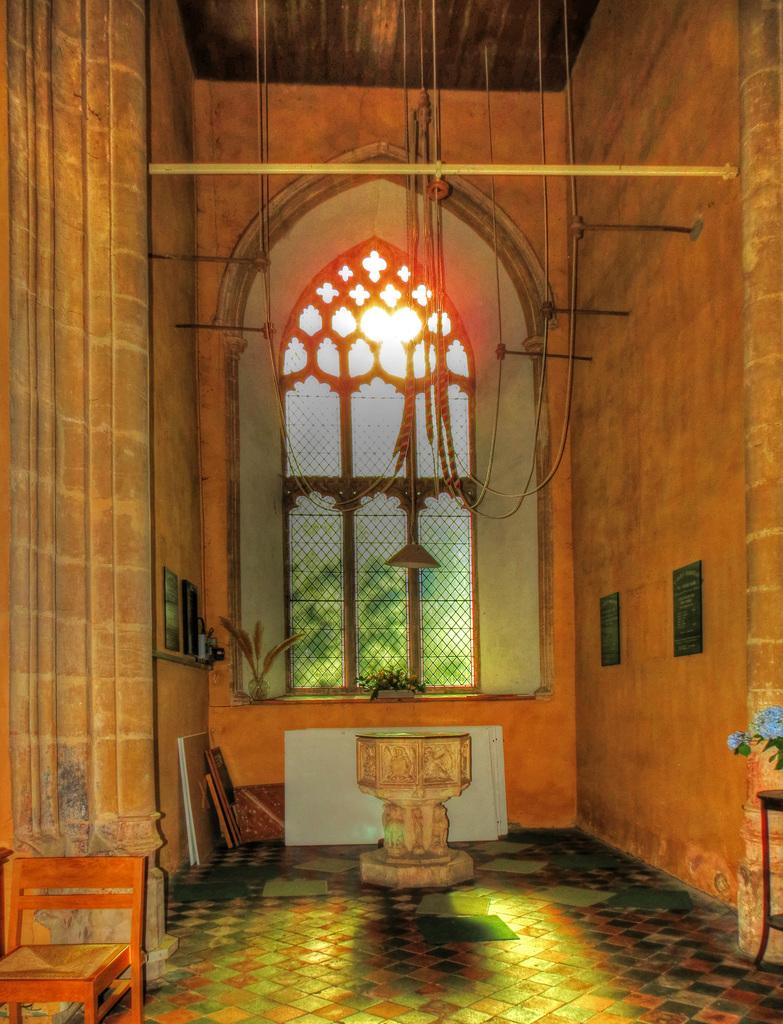What type of structures can be seen in the image? There are walls, a window, and pillars in the image. What architectural elements are present in the image? There are ropes and a chair in the image. What type of vegetation is visible in the image? There are plants in the image. What type of furniture is present in the image? There is a table in the image. What other objects can be seen in the image? There are objects in the image. What is on the walls in the image? Pictures are on the walls in the image. How many girls are playing with the chicken in the image? There are no girls or chickens present in the image. How many bikes are parked near the table in the image? There are no bikes present in the image. 